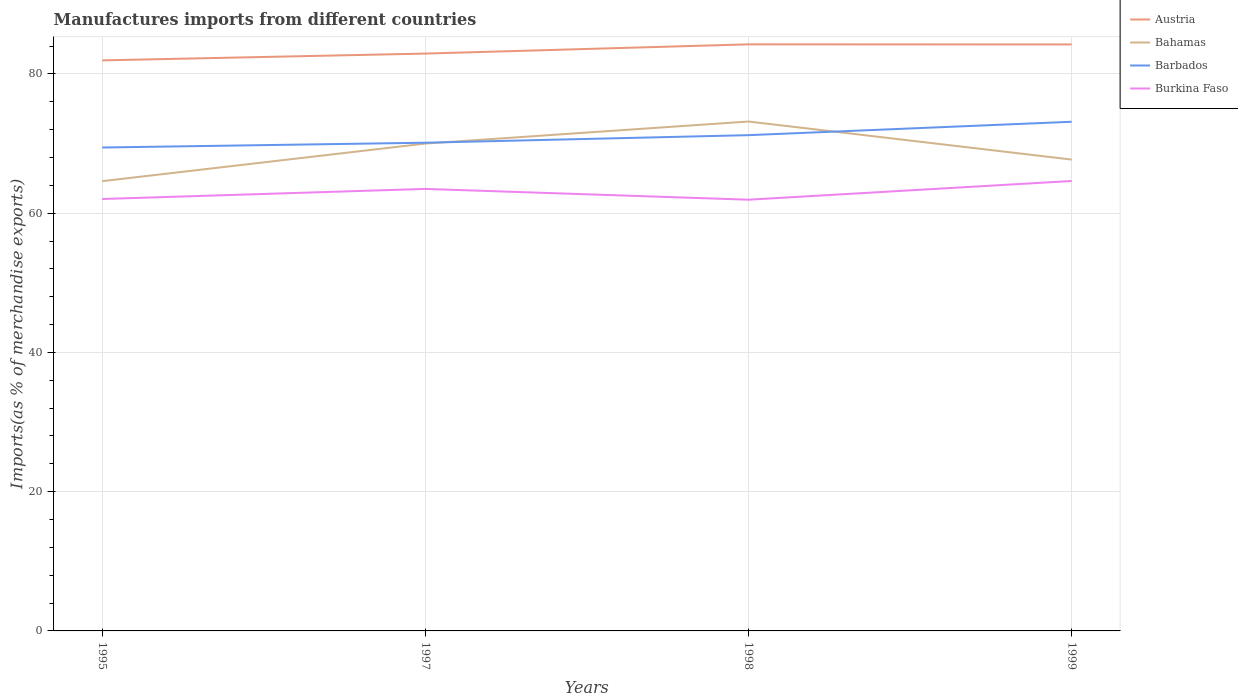Does the line corresponding to Burkina Faso intersect with the line corresponding to Barbados?
Offer a very short reply. No. Is the number of lines equal to the number of legend labels?
Keep it short and to the point. Yes. Across all years, what is the maximum percentage of imports to different countries in Burkina Faso?
Offer a very short reply. 61.93. What is the total percentage of imports to different countries in Austria in the graph?
Provide a succinct answer. 0.01. What is the difference between the highest and the second highest percentage of imports to different countries in Austria?
Give a very brief answer. 2.3. What is the difference between the highest and the lowest percentage of imports to different countries in Barbados?
Keep it short and to the point. 2. How many years are there in the graph?
Give a very brief answer. 4. What is the difference between two consecutive major ticks on the Y-axis?
Give a very brief answer. 20. Does the graph contain grids?
Keep it short and to the point. Yes. Where does the legend appear in the graph?
Offer a terse response. Top right. How many legend labels are there?
Your answer should be compact. 4. How are the legend labels stacked?
Your answer should be very brief. Vertical. What is the title of the graph?
Provide a succinct answer. Manufactures imports from different countries. What is the label or title of the X-axis?
Make the answer very short. Years. What is the label or title of the Y-axis?
Ensure brevity in your answer.  Imports(as % of merchandise exports). What is the Imports(as % of merchandise exports) in Austria in 1995?
Give a very brief answer. 81.94. What is the Imports(as % of merchandise exports) of Bahamas in 1995?
Ensure brevity in your answer.  64.6. What is the Imports(as % of merchandise exports) in Barbados in 1995?
Provide a succinct answer. 69.43. What is the Imports(as % of merchandise exports) of Burkina Faso in 1995?
Make the answer very short. 62.03. What is the Imports(as % of merchandise exports) in Austria in 1997?
Your answer should be compact. 82.92. What is the Imports(as % of merchandise exports) in Bahamas in 1997?
Provide a short and direct response. 70. What is the Imports(as % of merchandise exports) of Barbados in 1997?
Keep it short and to the point. 70.12. What is the Imports(as % of merchandise exports) in Burkina Faso in 1997?
Your response must be concise. 63.48. What is the Imports(as % of merchandise exports) in Austria in 1998?
Provide a short and direct response. 84.25. What is the Imports(as % of merchandise exports) of Bahamas in 1998?
Keep it short and to the point. 73.16. What is the Imports(as % of merchandise exports) of Barbados in 1998?
Keep it short and to the point. 71.2. What is the Imports(as % of merchandise exports) of Burkina Faso in 1998?
Offer a very short reply. 61.93. What is the Imports(as % of merchandise exports) of Austria in 1999?
Keep it short and to the point. 84.23. What is the Imports(as % of merchandise exports) of Bahamas in 1999?
Offer a terse response. 67.7. What is the Imports(as % of merchandise exports) of Barbados in 1999?
Offer a terse response. 73.13. What is the Imports(as % of merchandise exports) of Burkina Faso in 1999?
Provide a short and direct response. 64.62. Across all years, what is the maximum Imports(as % of merchandise exports) in Austria?
Give a very brief answer. 84.25. Across all years, what is the maximum Imports(as % of merchandise exports) of Bahamas?
Your answer should be compact. 73.16. Across all years, what is the maximum Imports(as % of merchandise exports) of Barbados?
Offer a very short reply. 73.13. Across all years, what is the maximum Imports(as % of merchandise exports) of Burkina Faso?
Make the answer very short. 64.62. Across all years, what is the minimum Imports(as % of merchandise exports) in Austria?
Your answer should be very brief. 81.94. Across all years, what is the minimum Imports(as % of merchandise exports) in Bahamas?
Your response must be concise. 64.6. Across all years, what is the minimum Imports(as % of merchandise exports) of Barbados?
Make the answer very short. 69.43. Across all years, what is the minimum Imports(as % of merchandise exports) of Burkina Faso?
Your answer should be very brief. 61.93. What is the total Imports(as % of merchandise exports) of Austria in the graph?
Provide a short and direct response. 333.34. What is the total Imports(as % of merchandise exports) of Bahamas in the graph?
Give a very brief answer. 275.45. What is the total Imports(as % of merchandise exports) in Barbados in the graph?
Offer a very short reply. 283.88. What is the total Imports(as % of merchandise exports) of Burkina Faso in the graph?
Offer a very short reply. 252.07. What is the difference between the Imports(as % of merchandise exports) in Austria in 1995 and that in 1997?
Provide a short and direct response. -0.98. What is the difference between the Imports(as % of merchandise exports) in Bahamas in 1995 and that in 1997?
Ensure brevity in your answer.  -5.4. What is the difference between the Imports(as % of merchandise exports) in Barbados in 1995 and that in 1997?
Provide a short and direct response. -0.69. What is the difference between the Imports(as % of merchandise exports) in Burkina Faso in 1995 and that in 1997?
Make the answer very short. -1.45. What is the difference between the Imports(as % of merchandise exports) in Austria in 1995 and that in 1998?
Your answer should be compact. -2.3. What is the difference between the Imports(as % of merchandise exports) in Bahamas in 1995 and that in 1998?
Give a very brief answer. -8.57. What is the difference between the Imports(as % of merchandise exports) in Barbados in 1995 and that in 1998?
Keep it short and to the point. -1.78. What is the difference between the Imports(as % of merchandise exports) in Burkina Faso in 1995 and that in 1998?
Your answer should be compact. 0.1. What is the difference between the Imports(as % of merchandise exports) of Austria in 1995 and that in 1999?
Provide a succinct answer. -2.29. What is the difference between the Imports(as % of merchandise exports) in Bahamas in 1995 and that in 1999?
Your answer should be compact. -3.1. What is the difference between the Imports(as % of merchandise exports) in Barbados in 1995 and that in 1999?
Give a very brief answer. -3.7. What is the difference between the Imports(as % of merchandise exports) of Burkina Faso in 1995 and that in 1999?
Your answer should be very brief. -2.59. What is the difference between the Imports(as % of merchandise exports) of Austria in 1997 and that in 1998?
Offer a very short reply. -1.33. What is the difference between the Imports(as % of merchandise exports) of Bahamas in 1997 and that in 1998?
Offer a terse response. -3.17. What is the difference between the Imports(as % of merchandise exports) in Barbados in 1997 and that in 1998?
Your answer should be compact. -1.09. What is the difference between the Imports(as % of merchandise exports) in Burkina Faso in 1997 and that in 1998?
Ensure brevity in your answer.  1.55. What is the difference between the Imports(as % of merchandise exports) of Austria in 1997 and that in 1999?
Keep it short and to the point. -1.31. What is the difference between the Imports(as % of merchandise exports) in Bahamas in 1997 and that in 1999?
Your answer should be very brief. 2.3. What is the difference between the Imports(as % of merchandise exports) of Barbados in 1997 and that in 1999?
Provide a succinct answer. -3.01. What is the difference between the Imports(as % of merchandise exports) in Burkina Faso in 1997 and that in 1999?
Your response must be concise. -1.14. What is the difference between the Imports(as % of merchandise exports) of Austria in 1998 and that in 1999?
Keep it short and to the point. 0.01. What is the difference between the Imports(as % of merchandise exports) in Bahamas in 1998 and that in 1999?
Offer a terse response. 5.47. What is the difference between the Imports(as % of merchandise exports) in Barbados in 1998 and that in 1999?
Offer a terse response. -1.92. What is the difference between the Imports(as % of merchandise exports) of Burkina Faso in 1998 and that in 1999?
Your answer should be very brief. -2.69. What is the difference between the Imports(as % of merchandise exports) of Austria in 1995 and the Imports(as % of merchandise exports) of Bahamas in 1997?
Provide a succinct answer. 11.95. What is the difference between the Imports(as % of merchandise exports) in Austria in 1995 and the Imports(as % of merchandise exports) in Barbados in 1997?
Your answer should be very brief. 11.83. What is the difference between the Imports(as % of merchandise exports) in Austria in 1995 and the Imports(as % of merchandise exports) in Burkina Faso in 1997?
Offer a very short reply. 18.46. What is the difference between the Imports(as % of merchandise exports) of Bahamas in 1995 and the Imports(as % of merchandise exports) of Barbados in 1997?
Your answer should be compact. -5.52. What is the difference between the Imports(as % of merchandise exports) of Bahamas in 1995 and the Imports(as % of merchandise exports) of Burkina Faso in 1997?
Offer a terse response. 1.11. What is the difference between the Imports(as % of merchandise exports) of Barbados in 1995 and the Imports(as % of merchandise exports) of Burkina Faso in 1997?
Give a very brief answer. 5.94. What is the difference between the Imports(as % of merchandise exports) of Austria in 1995 and the Imports(as % of merchandise exports) of Bahamas in 1998?
Make the answer very short. 8.78. What is the difference between the Imports(as % of merchandise exports) of Austria in 1995 and the Imports(as % of merchandise exports) of Barbados in 1998?
Your answer should be compact. 10.74. What is the difference between the Imports(as % of merchandise exports) of Austria in 1995 and the Imports(as % of merchandise exports) of Burkina Faso in 1998?
Give a very brief answer. 20.01. What is the difference between the Imports(as % of merchandise exports) in Bahamas in 1995 and the Imports(as % of merchandise exports) in Barbados in 1998?
Offer a very short reply. -6.61. What is the difference between the Imports(as % of merchandise exports) of Bahamas in 1995 and the Imports(as % of merchandise exports) of Burkina Faso in 1998?
Make the answer very short. 2.66. What is the difference between the Imports(as % of merchandise exports) in Barbados in 1995 and the Imports(as % of merchandise exports) in Burkina Faso in 1998?
Make the answer very short. 7.49. What is the difference between the Imports(as % of merchandise exports) in Austria in 1995 and the Imports(as % of merchandise exports) in Bahamas in 1999?
Give a very brief answer. 14.25. What is the difference between the Imports(as % of merchandise exports) in Austria in 1995 and the Imports(as % of merchandise exports) in Barbados in 1999?
Ensure brevity in your answer.  8.82. What is the difference between the Imports(as % of merchandise exports) in Austria in 1995 and the Imports(as % of merchandise exports) in Burkina Faso in 1999?
Give a very brief answer. 17.32. What is the difference between the Imports(as % of merchandise exports) in Bahamas in 1995 and the Imports(as % of merchandise exports) in Barbados in 1999?
Offer a terse response. -8.53. What is the difference between the Imports(as % of merchandise exports) in Bahamas in 1995 and the Imports(as % of merchandise exports) in Burkina Faso in 1999?
Your response must be concise. -0.02. What is the difference between the Imports(as % of merchandise exports) in Barbados in 1995 and the Imports(as % of merchandise exports) in Burkina Faso in 1999?
Provide a succinct answer. 4.81. What is the difference between the Imports(as % of merchandise exports) of Austria in 1997 and the Imports(as % of merchandise exports) of Bahamas in 1998?
Keep it short and to the point. 9.76. What is the difference between the Imports(as % of merchandise exports) of Austria in 1997 and the Imports(as % of merchandise exports) of Barbados in 1998?
Provide a succinct answer. 11.71. What is the difference between the Imports(as % of merchandise exports) of Austria in 1997 and the Imports(as % of merchandise exports) of Burkina Faso in 1998?
Offer a terse response. 20.99. What is the difference between the Imports(as % of merchandise exports) in Bahamas in 1997 and the Imports(as % of merchandise exports) in Barbados in 1998?
Offer a terse response. -1.21. What is the difference between the Imports(as % of merchandise exports) in Bahamas in 1997 and the Imports(as % of merchandise exports) in Burkina Faso in 1998?
Ensure brevity in your answer.  8.06. What is the difference between the Imports(as % of merchandise exports) in Barbados in 1997 and the Imports(as % of merchandise exports) in Burkina Faso in 1998?
Give a very brief answer. 8.18. What is the difference between the Imports(as % of merchandise exports) in Austria in 1997 and the Imports(as % of merchandise exports) in Bahamas in 1999?
Offer a terse response. 15.22. What is the difference between the Imports(as % of merchandise exports) in Austria in 1997 and the Imports(as % of merchandise exports) in Barbados in 1999?
Offer a very short reply. 9.79. What is the difference between the Imports(as % of merchandise exports) in Austria in 1997 and the Imports(as % of merchandise exports) in Burkina Faso in 1999?
Keep it short and to the point. 18.3. What is the difference between the Imports(as % of merchandise exports) in Bahamas in 1997 and the Imports(as % of merchandise exports) in Barbados in 1999?
Ensure brevity in your answer.  -3.13. What is the difference between the Imports(as % of merchandise exports) of Bahamas in 1997 and the Imports(as % of merchandise exports) of Burkina Faso in 1999?
Your answer should be very brief. 5.37. What is the difference between the Imports(as % of merchandise exports) in Barbados in 1997 and the Imports(as % of merchandise exports) in Burkina Faso in 1999?
Your answer should be very brief. 5.5. What is the difference between the Imports(as % of merchandise exports) in Austria in 1998 and the Imports(as % of merchandise exports) in Bahamas in 1999?
Your answer should be very brief. 16.55. What is the difference between the Imports(as % of merchandise exports) of Austria in 1998 and the Imports(as % of merchandise exports) of Barbados in 1999?
Your answer should be compact. 11.12. What is the difference between the Imports(as % of merchandise exports) of Austria in 1998 and the Imports(as % of merchandise exports) of Burkina Faso in 1999?
Provide a succinct answer. 19.63. What is the difference between the Imports(as % of merchandise exports) in Bahamas in 1998 and the Imports(as % of merchandise exports) in Barbados in 1999?
Your response must be concise. 0.04. What is the difference between the Imports(as % of merchandise exports) in Bahamas in 1998 and the Imports(as % of merchandise exports) in Burkina Faso in 1999?
Offer a terse response. 8.54. What is the difference between the Imports(as % of merchandise exports) of Barbados in 1998 and the Imports(as % of merchandise exports) of Burkina Faso in 1999?
Provide a succinct answer. 6.58. What is the average Imports(as % of merchandise exports) in Austria per year?
Your answer should be very brief. 83.34. What is the average Imports(as % of merchandise exports) in Bahamas per year?
Your response must be concise. 68.86. What is the average Imports(as % of merchandise exports) of Barbados per year?
Make the answer very short. 70.97. What is the average Imports(as % of merchandise exports) in Burkina Faso per year?
Make the answer very short. 63.02. In the year 1995, what is the difference between the Imports(as % of merchandise exports) of Austria and Imports(as % of merchandise exports) of Bahamas?
Offer a terse response. 17.35. In the year 1995, what is the difference between the Imports(as % of merchandise exports) of Austria and Imports(as % of merchandise exports) of Barbados?
Provide a short and direct response. 12.52. In the year 1995, what is the difference between the Imports(as % of merchandise exports) in Austria and Imports(as % of merchandise exports) in Burkina Faso?
Your answer should be very brief. 19.91. In the year 1995, what is the difference between the Imports(as % of merchandise exports) of Bahamas and Imports(as % of merchandise exports) of Barbados?
Your answer should be compact. -4.83. In the year 1995, what is the difference between the Imports(as % of merchandise exports) of Bahamas and Imports(as % of merchandise exports) of Burkina Faso?
Provide a succinct answer. 2.56. In the year 1995, what is the difference between the Imports(as % of merchandise exports) in Barbados and Imports(as % of merchandise exports) in Burkina Faso?
Offer a terse response. 7.39. In the year 1997, what is the difference between the Imports(as % of merchandise exports) of Austria and Imports(as % of merchandise exports) of Bahamas?
Offer a very short reply. 12.92. In the year 1997, what is the difference between the Imports(as % of merchandise exports) in Austria and Imports(as % of merchandise exports) in Barbados?
Keep it short and to the point. 12.8. In the year 1997, what is the difference between the Imports(as % of merchandise exports) in Austria and Imports(as % of merchandise exports) in Burkina Faso?
Your answer should be compact. 19.44. In the year 1997, what is the difference between the Imports(as % of merchandise exports) of Bahamas and Imports(as % of merchandise exports) of Barbados?
Provide a succinct answer. -0.12. In the year 1997, what is the difference between the Imports(as % of merchandise exports) in Bahamas and Imports(as % of merchandise exports) in Burkina Faso?
Your answer should be very brief. 6.51. In the year 1997, what is the difference between the Imports(as % of merchandise exports) of Barbados and Imports(as % of merchandise exports) of Burkina Faso?
Provide a short and direct response. 6.63. In the year 1998, what is the difference between the Imports(as % of merchandise exports) in Austria and Imports(as % of merchandise exports) in Bahamas?
Provide a succinct answer. 11.08. In the year 1998, what is the difference between the Imports(as % of merchandise exports) of Austria and Imports(as % of merchandise exports) of Barbados?
Offer a very short reply. 13.04. In the year 1998, what is the difference between the Imports(as % of merchandise exports) of Austria and Imports(as % of merchandise exports) of Burkina Faso?
Make the answer very short. 22.31. In the year 1998, what is the difference between the Imports(as % of merchandise exports) of Bahamas and Imports(as % of merchandise exports) of Barbados?
Offer a terse response. 1.96. In the year 1998, what is the difference between the Imports(as % of merchandise exports) of Bahamas and Imports(as % of merchandise exports) of Burkina Faso?
Offer a terse response. 11.23. In the year 1998, what is the difference between the Imports(as % of merchandise exports) in Barbados and Imports(as % of merchandise exports) in Burkina Faso?
Your answer should be compact. 9.27. In the year 1999, what is the difference between the Imports(as % of merchandise exports) in Austria and Imports(as % of merchandise exports) in Bahamas?
Keep it short and to the point. 16.54. In the year 1999, what is the difference between the Imports(as % of merchandise exports) in Austria and Imports(as % of merchandise exports) in Barbados?
Your response must be concise. 11.1. In the year 1999, what is the difference between the Imports(as % of merchandise exports) of Austria and Imports(as % of merchandise exports) of Burkina Faso?
Keep it short and to the point. 19.61. In the year 1999, what is the difference between the Imports(as % of merchandise exports) of Bahamas and Imports(as % of merchandise exports) of Barbados?
Make the answer very short. -5.43. In the year 1999, what is the difference between the Imports(as % of merchandise exports) in Bahamas and Imports(as % of merchandise exports) in Burkina Faso?
Offer a very short reply. 3.08. In the year 1999, what is the difference between the Imports(as % of merchandise exports) in Barbados and Imports(as % of merchandise exports) in Burkina Faso?
Give a very brief answer. 8.51. What is the ratio of the Imports(as % of merchandise exports) of Bahamas in 1995 to that in 1997?
Keep it short and to the point. 0.92. What is the ratio of the Imports(as % of merchandise exports) in Barbados in 1995 to that in 1997?
Provide a succinct answer. 0.99. What is the ratio of the Imports(as % of merchandise exports) in Burkina Faso in 1995 to that in 1997?
Offer a very short reply. 0.98. What is the ratio of the Imports(as % of merchandise exports) of Austria in 1995 to that in 1998?
Give a very brief answer. 0.97. What is the ratio of the Imports(as % of merchandise exports) of Bahamas in 1995 to that in 1998?
Your response must be concise. 0.88. What is the ratio of the Imports(as % of merchandise exports) of Barbados in 1995 to that in 1998?
Ensure brevity in your answer.  0.98. What is the ratio of the Imports(as % of merchandise exports) in Austria in 1995 to that in 1999?
Make the answer very short. 0.97. What is the ratio of the Imports(as % of merchandise exports) of Bahamas in 1995 to that in 1999?
Your response must be concise. 0.95. What is the ratio of the Imports(as % of merchandise exports) of Barbados in 1995 to that in 1999?
Give a very brief answer. 0.95. What is the ratio of the Imports(as % of merchandise exports) in Austria in 1997 to that in 1998?
Offer a terse response. 0.98. What is the ratio of the Imports(as % of merchandise exports) of Bahamas in 1997 to that in 1998?
Keep it short and to the point. 0.96. What is the ratio of the Imports(as % of merchandise exports) of Barbados in 1997 to that in 1998?
Your answer should be very brief. 0.98. What is the ratio of the Imports(as % of merchandise exports) in Burkina Faso in 1997 to that in 1998?
Provide a short and direct response. 1.02. What is the ratio of the Imports(as % of merchandise exports) of Austria in 1997 to that in 1999?
Provide a succinct answer. 0.98. What is the ratio of the Imports(as % of merchandise exports) in Bahamas in 1997 to that in 1999?
Give a very brief answer. 1.03. What is the ratio of the Imports(as % of merchandise exports) of Barbados in 1997 to that in 1999?
Make the answer very short. 0.96. What is the ratio of the Imports(as % of merchandise exports) of Burkina Faso in 1997 to that in 1999?
Offer a very short reply. 0.98. What is the ratio of the Imports(as % of merchandise exports) of Austria in 1998 to that in 1999?
Make the answer very short. 1. What is the ratio of the Imports(as % of merchandise exports) in Bahamas in 1998 to that in 1999?
Your response must be concise. 1.08. What is the ratio of the Imports(as % of merchandise exports) of Barbados in 1998 to that in 1999?
Make the answer very short. 0.97. What is the ratio of the Imports(as % of merchandise exports) in Burkina Faso in 1998 to that in 1999?
Your answer should be very brief. 0.96. What is the difference between the highest and the second highest Imports(as % of merchandise exports) in Austria?
Ensure brevity in your answer.  0.01. What is the difference between the highest and the second highest Imports(as % of merchandise exports) of Bahamas?
Your answer should be compact. 3.17. What is the difference between the highest and the second highest Imports(as % of merchandise exports) of Barbados?
Ensure brevity in your answer.  1.92. What is the difference between the highest and the second highest Imports(as % of merchandise exports) in Burkina Faso?
Ensure brevity in your answer.  1.14. What is the difference between the highest and the lowest Imports(as % of merchandise exports) of Austria?
Provide a short and direct response. 2.3. What is the difference between the highest and the lowest Imports(as % of merchandise exports) in Bahamas?
Provide a short and direct response. 8.57. What is the difference between the highest and the lowest Imports(as % of merchandise exports) of Barbados?
Make the answer very short. 3.7. What is the difference between the highest and the lowest Imports(as % of merchandise exports) of Burkina Faso?
Give a very brief answer. 2.69. 